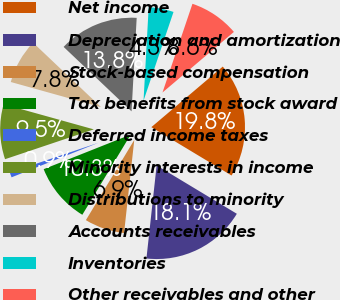Convert chart. <chart><loc_0><loc_0><loc_500><loc_500><pie_chart><fcel>Net income<fcel>Depreciation and amortization<fcel>Stock-based compensation<fcel>Tax benefits from stock award<fcel>Deferred income taxes<fcel>Minority interests in income<fcel>Distributions to minority<fcel>Accounts receivables<fcel>Inventories<fcel>Other receivables and other<nl><fcel>19.83%<fcel>18.1%<fcel>6.9%<fcel>10.34%<fcel>0.86%<fcel>9.48%<fcel>7.76%<fcel>13.79%<fcel>4.31%<fcel>8.62%<nl></chart> 